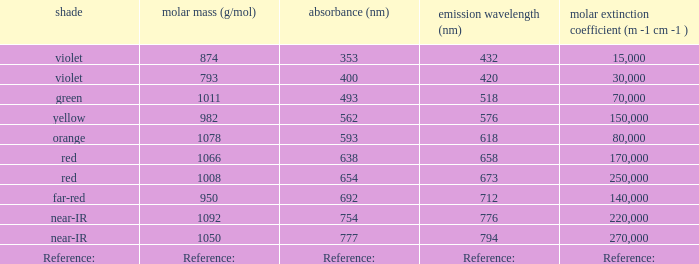Parse the table in full. {'header': ['shade', 'molar mass (g/mol)', 'absorbance (nm)', 'emission wavelength (nm)', 'molar extinction coefficient (m -1 cm -1 )'], 'rows': [['violet', '874', '353', '432', '15,000'], ['violet', '793', '400', '420', '30,000'], ['green', '1011', '493', '518', '70,000'], ['yellow', '982', '562', '576', '150,000'], ['orange', '1078', '593', '618', '80,000'], ['red', '1066', '638', '658', '170,000'], ['red', '1008', '654', '673', '250,000'], ['far-red', '950', '692', '712', '140,000'], ['near-IR', '1092', '754', '776', '220,000'], ['near-IR', '1050', '777', '794', '270,000'], ['Reference:', 'Reference:', 'Reference:', 'Reference:', 'Reference:']]} Which Emission (in nanometers) that has a molar mass of 1078 g/mol? 618.0. 